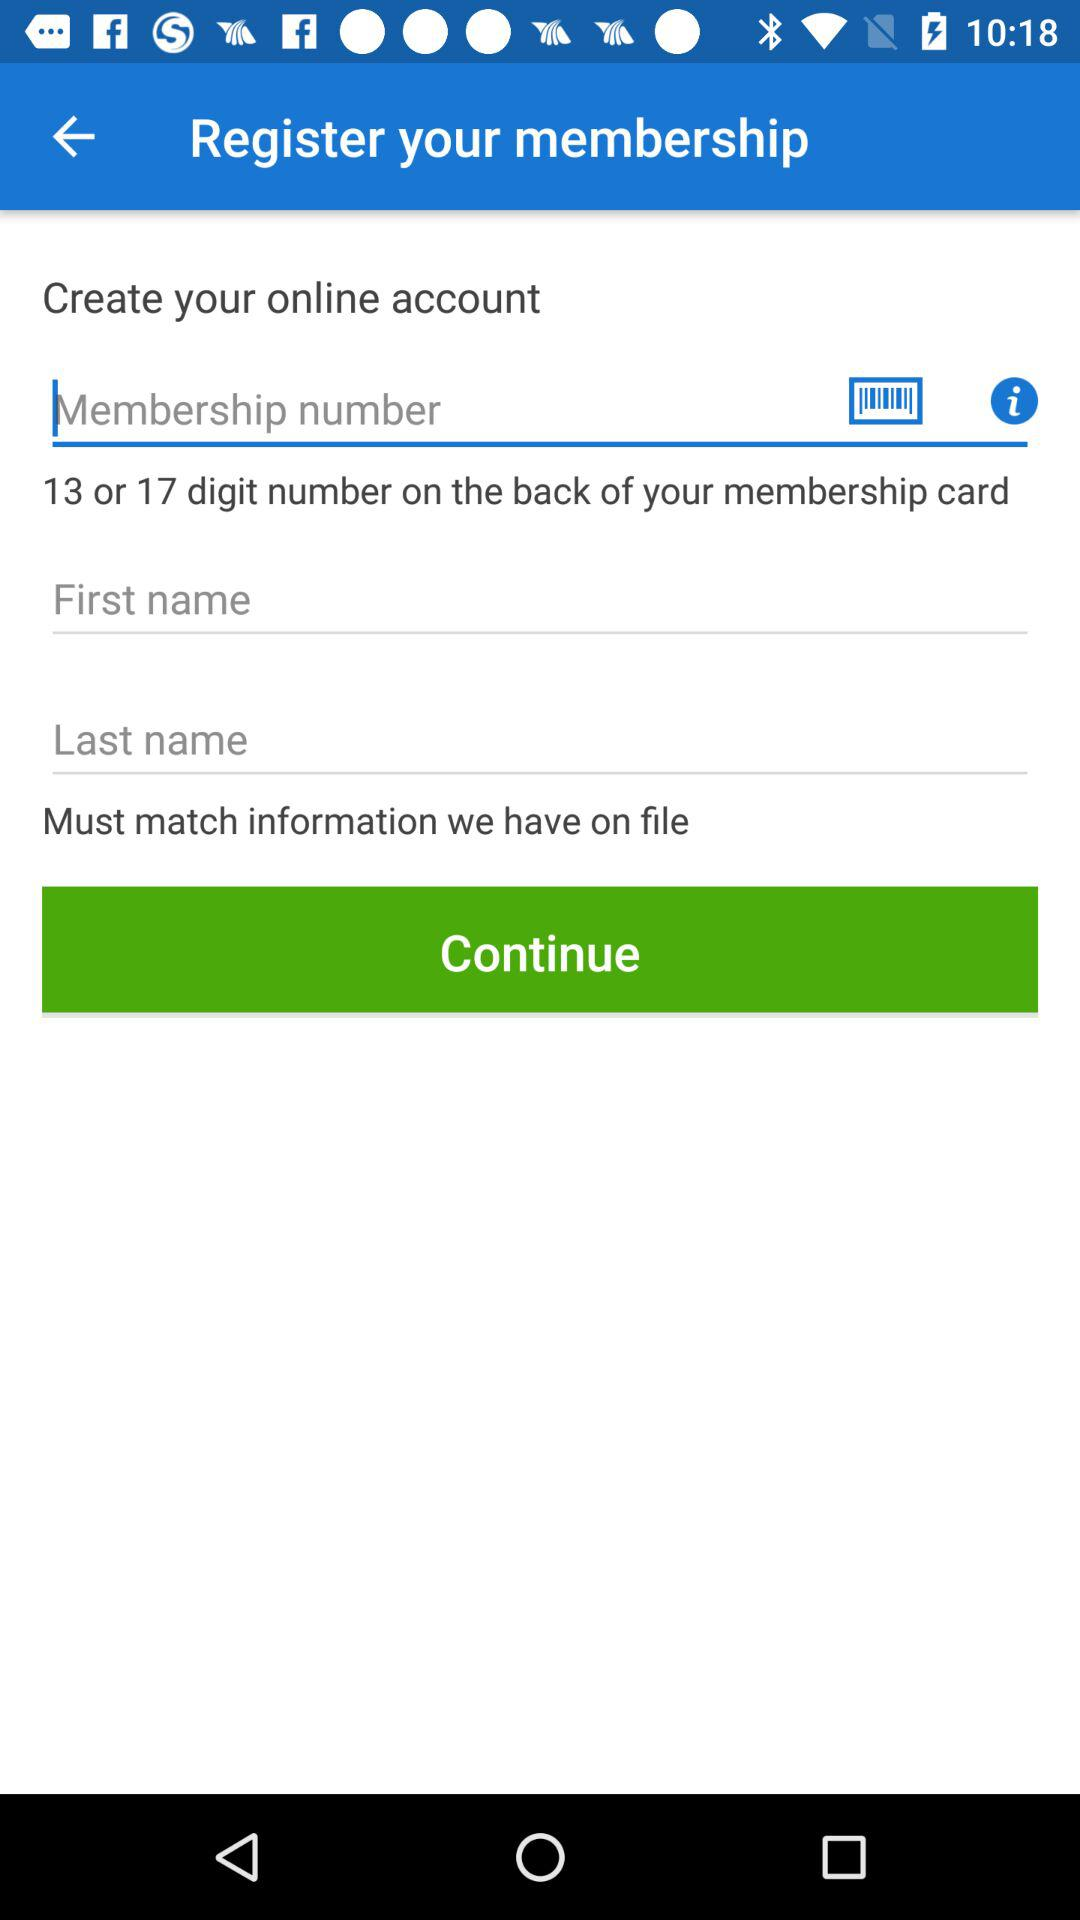How many digits are there on the membership card? There are 13 or 17 digit numbers on the back of the membership card. 